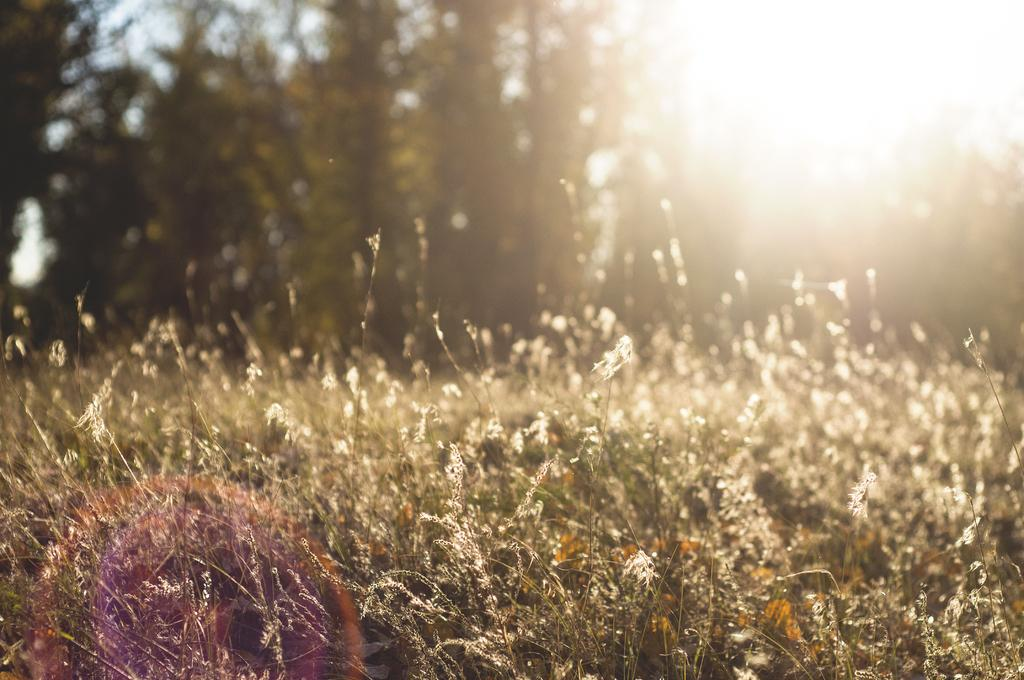Where was the image taken from? The image was taken from outside the city. What can be seen in the image besides the city? There are plants and trees in the image. What is visible in the background of the image? There are trees in the background of the image. What color is present at the top of the image? The top of the image contains a white color, which could be the sky or a cloud. Is there a woman in the image connecting her phone to the tail of a bird? No, there is no woman or bird with a tail present in the image. 